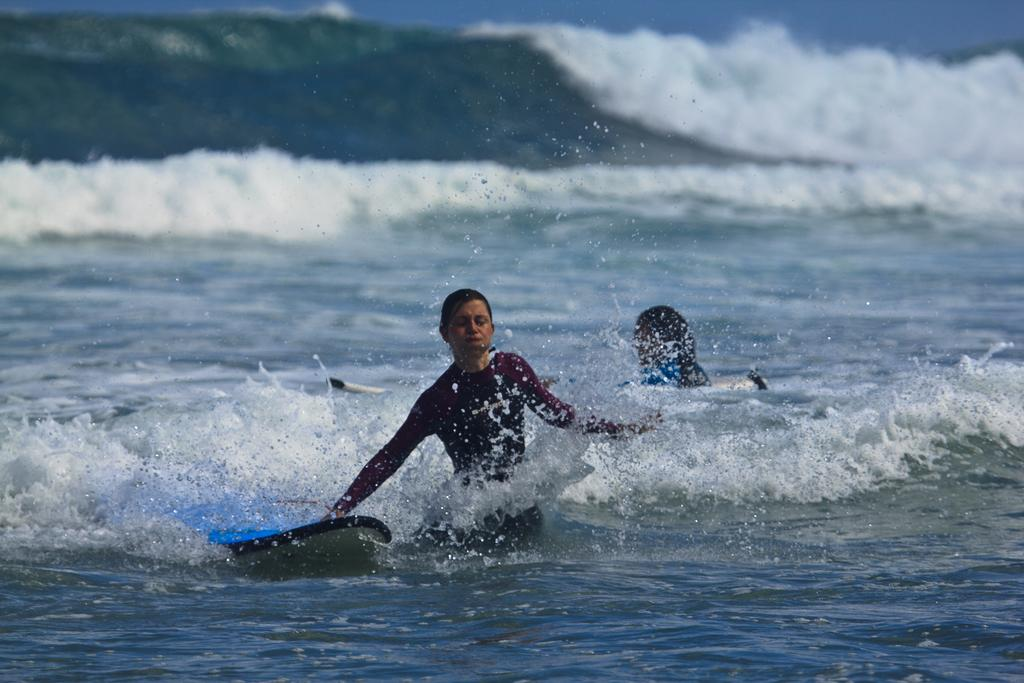What is present in the image? There are persons and surf boats in the image. What type of environment can be seen in the image? Water waves and water are visible in the image. What year is depicted in the image? The provided facts do not mention any specific year, so it is not possible to determine the year from the image. What type of stamp is visible on the persons in the image? There is no mention of any stamps on the persons in the image. 